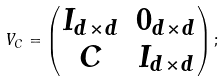Convert formula to latex. <formula><loc_0><loc_0><loc_500><loc_500>V _ { C } = \begin{pmatrix} I _ { d \times d } & 0 _ { d \times d } \\ C & I _ { d \times d } \end{pmatrix} ;</formula> 